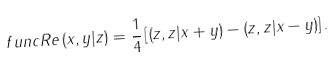Convert formula to latex. <formula><loc_0><loc_0><loc_500><loc_500>\ f u n c { R e } \left ( x , y | z \right ) = \frac { 1 } { 4 } \left [ \left ( z , z | x + y \right ) - \left ( z , z | x - y \right ) \right ] .</formula> 